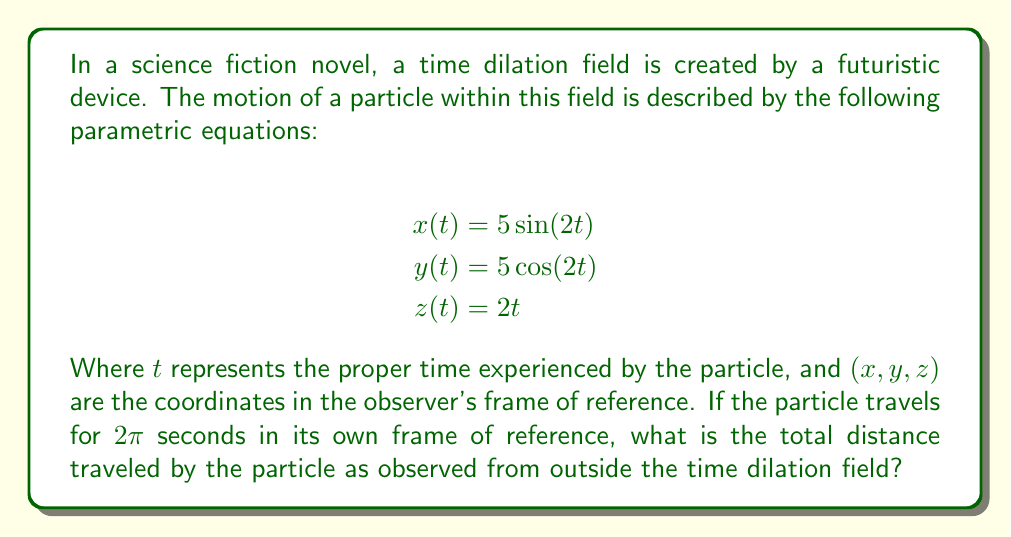Can you solve this math problem? To solve this problem, we need to follow these steps:

1) First, we need to understand that the particle is moving in a helical path. The x and y equations describe a circle in the xy-plane, while the z equation shows linear motion along the z-axis.

2) To find the total distance traveled, we need to calculate the arc length of this helical path. The arc length formula for parametric equations in 3D space is:

   $$s = \int_a^b \sqrt{\left(\frac{dx}{dt}\right)^2 + \left(\frac{dy}{dt}\right)^2 + \left(\frac{dz}{dt}\right)^2} dt$$

3) Let's calculate the derivatives:
   
   $$\frac{dx}{dt} = 10\cos(2t)$$
   $$\frac{dy}{dt} = -10\sin(2t)$$
   $$\frac{dz}{dt} = 2$$

4) Now, let's substitute these into our arc length formula:

   $$s = \int_0^{2\pi} \sqrt{(10\cos(2t))^2 + (-10\sin(2t))^2 + 2^2} dt$$

5) Simplify under the square root:

   $$s = \int_0^{2\pi} \sqrt{100\cos^2(2t) + 100\sin^2(2t) + 4} dt$$

6) Recall that $\cos^2(2t) + \sin^2(2t) = 1$ for all $t$, so:

   $$s = \int_0^{2\pi} \sqrt{100 + 4} dt = \int_0^{2\pi} \sqrt{104} dt = \int_0^{2\pi} 2\sqrt{26} dt$$

7) This integral is now straightforward:

   $$s = 2\sqrt{26} \cdot 2\pi = 4\pi\sqrt{26}$$

Thus, the total distance traveled by the particle as observed from outside the time dilation field is $4\pi\sqrt{26}$ units.
Answer: $4\pi\sqrt{26}$ units 